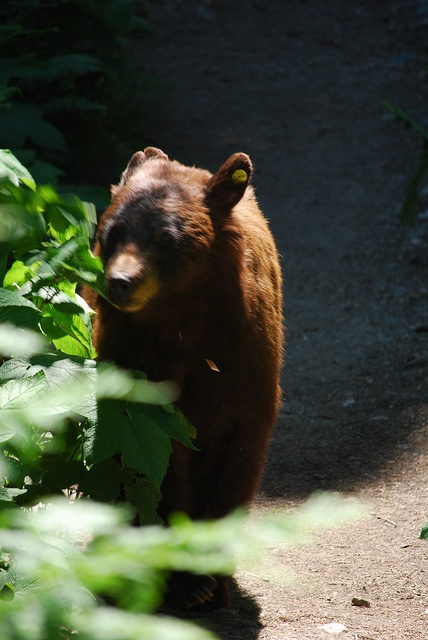Describe the objects in this image and their specific colors. I can see a bear in black, maroon, olive, and tan tones in this image. 